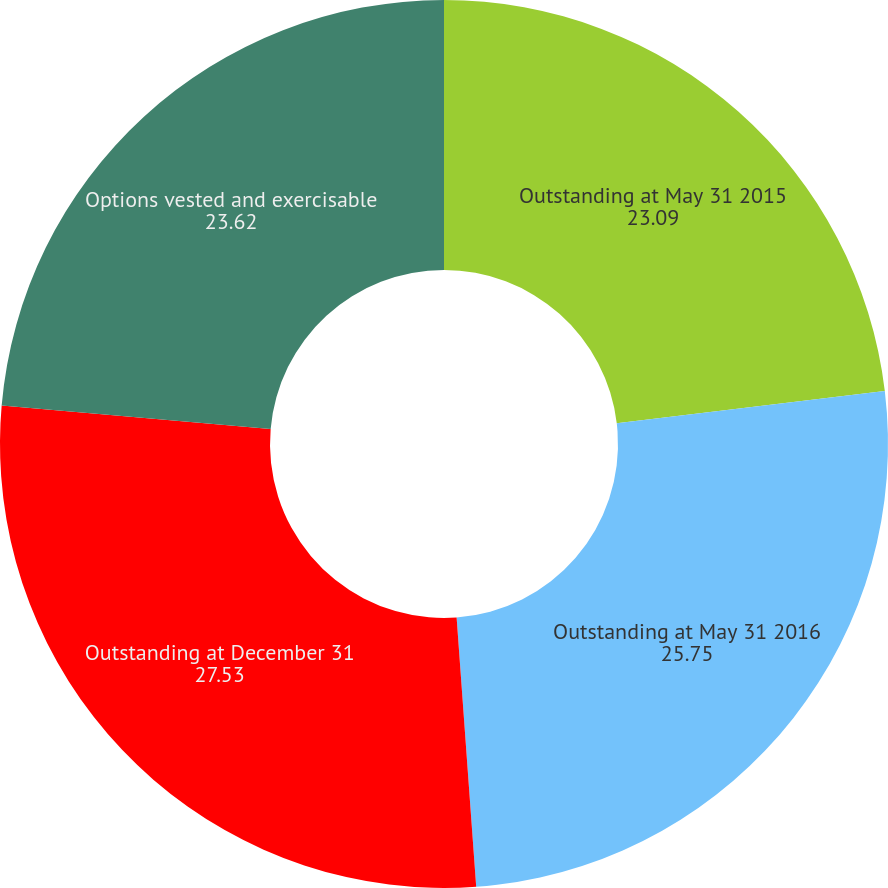Convert chart. <chart><loc_0><loc_0><loc_500><loc_500><pie_chart><fcel>Outstanding at May 31 2015<fcel>Outstanding at May 31 2016<fcel>Outstanding at December 31<fcel>Options vested and exercisable<nl><fcel>23.09%<fcel>25.75%<fcel>27.53%<fcel>23.62%<nl></chart> 